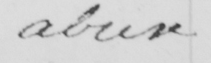Please transcribe the handwritten text in this image. abuse 